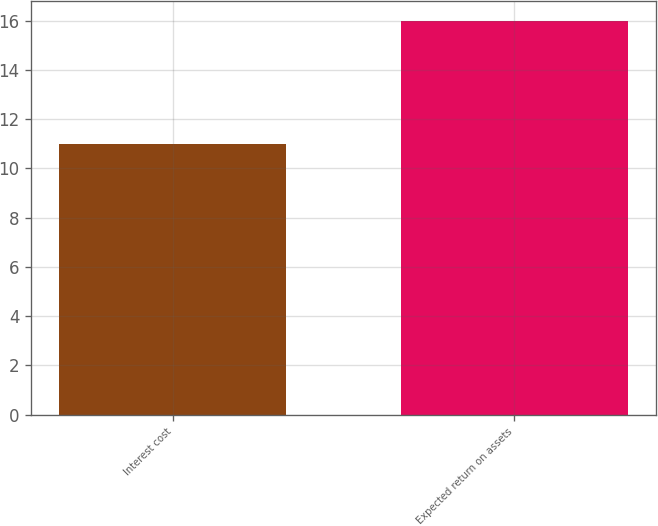Convert chart. <chart><loc_0><loc_0><loc_500><loc_500><bar_chart><fcel>Interest cost<fcel>Expected return on assets<nl><fcel>11<fcel>16<nl></chart> 